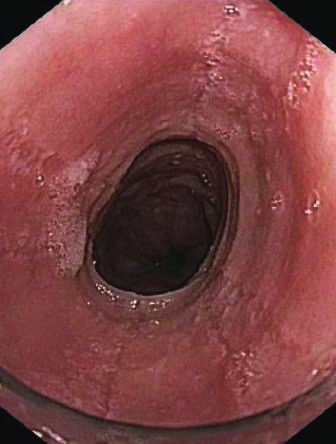what does endoscopy reveal?
Answer the question using a single word or phrase. Circumferential rings in the proximal esophagus 